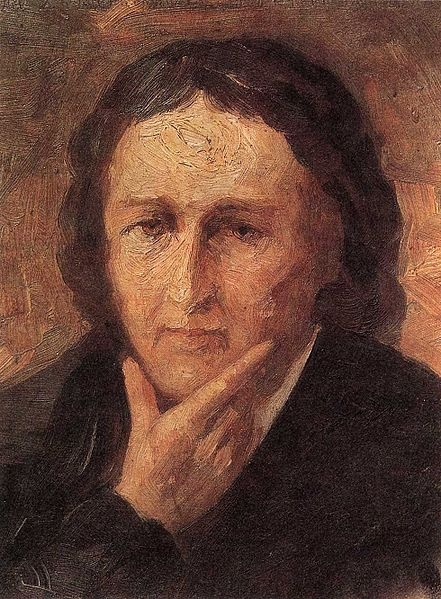If you could step into the painting and talk to this person, what would you ask? If I could step into the painting and converse with the individual, I would ask, 'What thoughts are occupying your mind so deeply? What story lies behind those thoughtful eyes?' This question aims to uncover the personal narrative and emotions that the individual is experiencing, which are so vividly captured in their expression. 